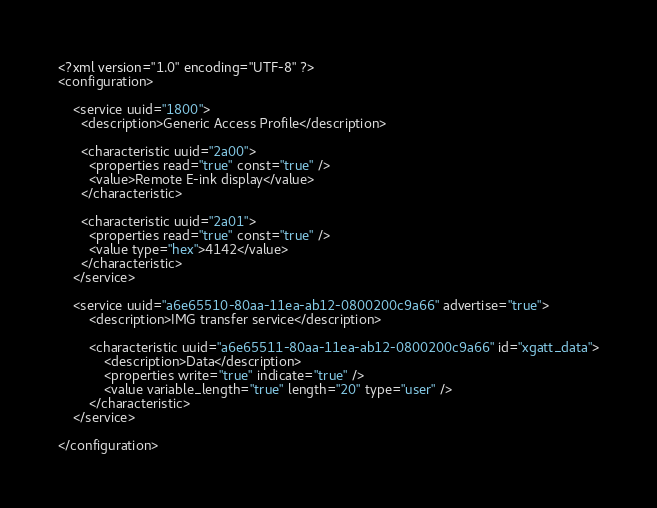Convert code to text. <code><loc_0><loc_0><loc_500><loc_500><_XML_><?xml version="1.0" encoding="UTF-8" ?>
<configuration>

    <service uuid="1800">
      <description>Generic Access Profile</description>

      <characteristic uuid="2a00">
        <properties read="true" const="true" />
        <value>Remote E-ink display</value>
      </characteristic>

      <characteristic uuid="2a01">
        <properties read="true" const="true" />
        <value type="hex">4142</value>
      </characteristic>
    </service>
    
    <service uuid="a6e65510-80aa-11ea-ab12-0800200c9a66" advertise="true">
        <description>IMG transfer service</description>
        
        <characteristic uuid="a6e65511-80aa-11ea-ab12-0800200c9a66" id="xgatt_data">
            <description>Data</description>
            <properties write="true" indicate="true" />
            <value variable_length="true" length="20" type="user" />
        </characteristic>
    </service>
    
</configuration>
</code> 